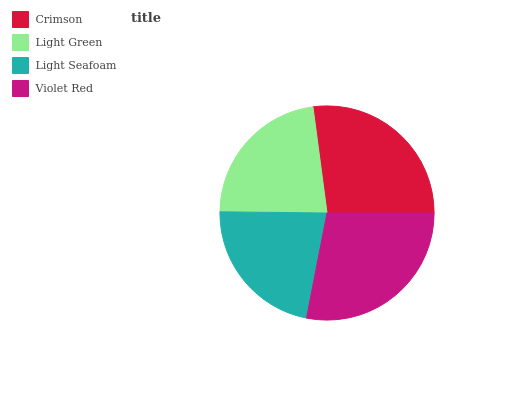Is Light Seafoam the minimum?
Answer yes or no. Yes. Is Violet Red the maximum?
Answer yes or no. Yes. Is Light Green the minimum?
Answer yes or no. No. Is Light Green the maximum?
Answer yes or no. No. Is Crimson greater than Light Green?
Answer yes or no. Yes. Is Light Green less than Crimson?
Answer yes or no. Yes. Is Light Green greater than Crimson?
Answer yes or no. No. Is Crimson less than Light Green?
Answer yes or no. No. Is Crimson the high median?
Answer yes or no. Yes. Is Light Green the low median?
Answer yes or no. Yes. Is Violet Red the high median?
Answer yes or no. No. Is Violet Red the low median?
Answer yes or no. No. 